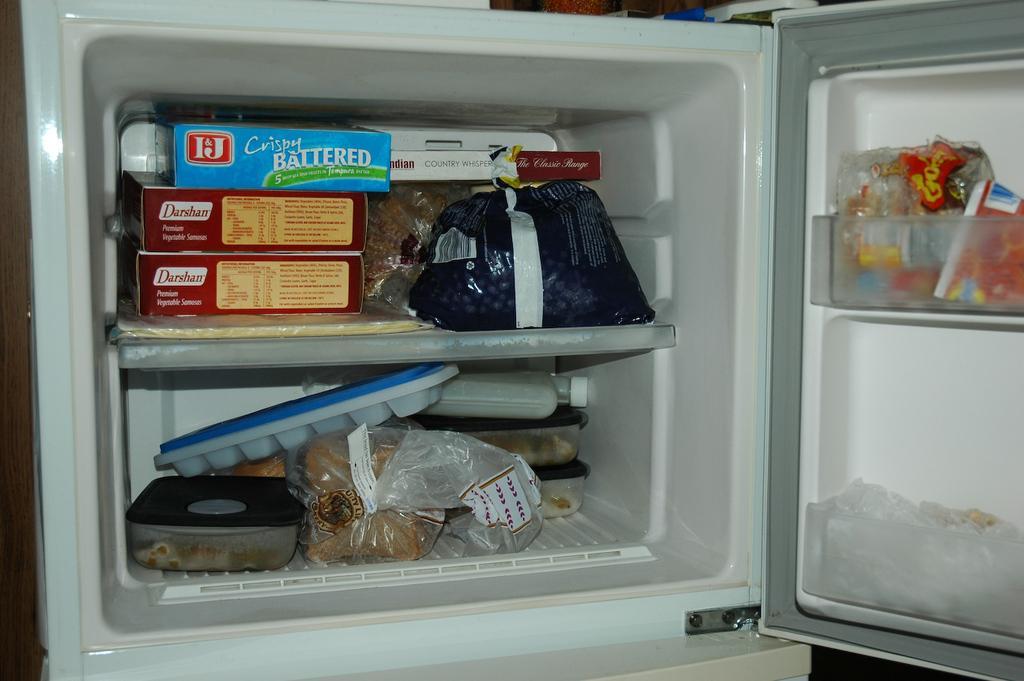Describe this image in one or two sentences. In this image in the center there is a fridge and in the fridge there are some boxes, ice cubes, tray, covers and some other objects. In the background there are some other objects. 